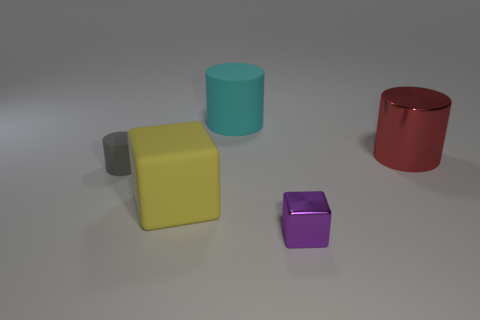Is the number of cylinders right of the gray cylinder the same as the number of tiny purple shiny cubes that are behind the large cyan rubber object?
Your response must be concise. No. There is a cylinder that is right of the small gray cylinder and left of the small block; what is its material?
Make the answer very short. Rubber. Does the gray cylinder have the same size as the metallic thing that is in front of the red cylinder?
Your answer should be compact. Yes. Are there more matte things that are in front of the large cyan rubber thing than large cubes?
Provide a short and direct response. Yes. The big rubber object that is on the left side of the large cylinder left of the small object that is in front of the gray cylinder is what color?
Give a very brief answer. Yellow. Do the gray cylinder and the tiny block have the same material?
Keep it short and to the point. No. Is there a red shiny object that has the same size as the cyan cylinder?
Keep it short and to the point. Yes. There is a yellow block that is the same size as the red object; what material is it?
Make the answer very short. Rubber. Are there any other rubber things of the same shape as the cyan thing?
Offer a very short reply. Yes. There is a metal object that is to the right of the purple shiny object; what is its shape?
Offer a terse response. Cylinder. 